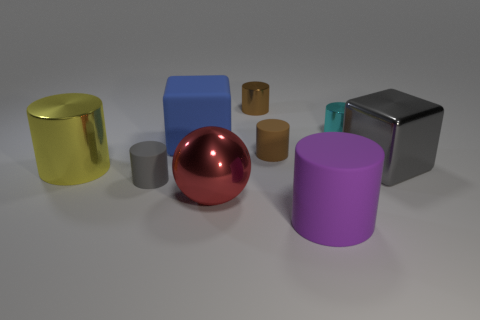What number of shiny objects are either large purple things or blocks?
Provide a succinct answer. 1. There is a purple cylinder that is the same size as the red metallic sphere; what is it made of?
Provide a succinct answer. Rubber. How many other objects are there of the same material as the large purple cylinder?
Keep it short and to the point. 3. Are there fewer big rubber cubes that are right of the big sphere than big gray matte blocks?
Keep it short and to the point. No. Is the shape of the gray matte object the same as the cyan shiny thing?
Your answer should be very brief. Yes. There is a gray thing behind the metallic cylinder that is to the left of the rubber cylinder that is on the left side of the red ball; how big is it?
Your answer should be very brief. Large. There is a large yellow thing that is the same shape as the brown matte thing; what material is it?
Provide a succinct answer. Metal. How big is the metallic cylinder that is in front of the large rubber thing that is behind the large yellow object?
Your answer should be compact. Large. What color is the ball?
Your response must be concise. Red. There is a brown cylinder behind the brown rubber thing; what number of large red metallic things are behind it?
Make the answer very short. 0. 